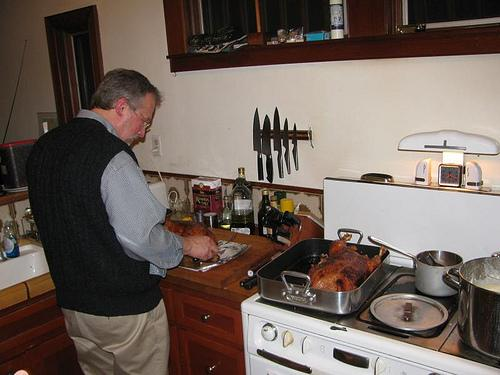What is the time shown on the clock in the kitchen? The clock shows twenty past seven. In what manner are the knives arranged on the rack, and which direction are the pointed sides facing? Knives are arranged one beside the other on the rack, with pointed sides facing up. Identify the primary human subject, what they're wearing, and what they're doing in the kitchen. The primary human subject is an older man wearing a black sweater and brown pants, cooking in the kitchen. What is the man doing with his right hand and how is he preventing stains on his shirt? The man is touching the meat with his right hand and has turned up his sleeves to prevent stains. Which objects can be found on the back counter of the kitchen? Bottles, packages, and knives can be found on the back counter. Describe the situation of the window in the image. The windows are dark with packages placed on the sills. Give a brief overview of the scene in the image. An older man is cooking in the kitchen, wearing black sweater and khaki pants, surrounded by various objects like roasted chicken, pots, and knives. What kind of clothing is the man in the image wearing? The man is wearing a black sweater, gray shirt inside, and brown color pants. What kind of action is the woman in white performing, and how many instances of it can you see in the image? The woman in white is swinging a tennis racket, and there are 17 instances in the image. What sits next to the roasted chicken in the kitchen and what is their position? Pots and lids are placed on top of the stove, next to the roasted chicken. Identify the steaming cup of coffee placed next to the oven in the kitchen. Its aroma must be filling the room as the man cooks. Find the toddler sitting on a high chair at the edge of the image. Could the man be preparing a meal for the child? Point out the colorful painting hanging on the wall above the stove. What do you think the artist was trying to express? Can you spot the flamingo statue standing between the pots and lids on the stove? It is an unusual decorative item for a kitchen. Observe the red apple placed in the fruit bowl in the center of the back counter. Isn't it interesting how bright the color is compared to its surroundings? Can you find the cat sitting on the countertop next to the roasted chicken? Notice its fur is similar in color to the roasted chicken. 